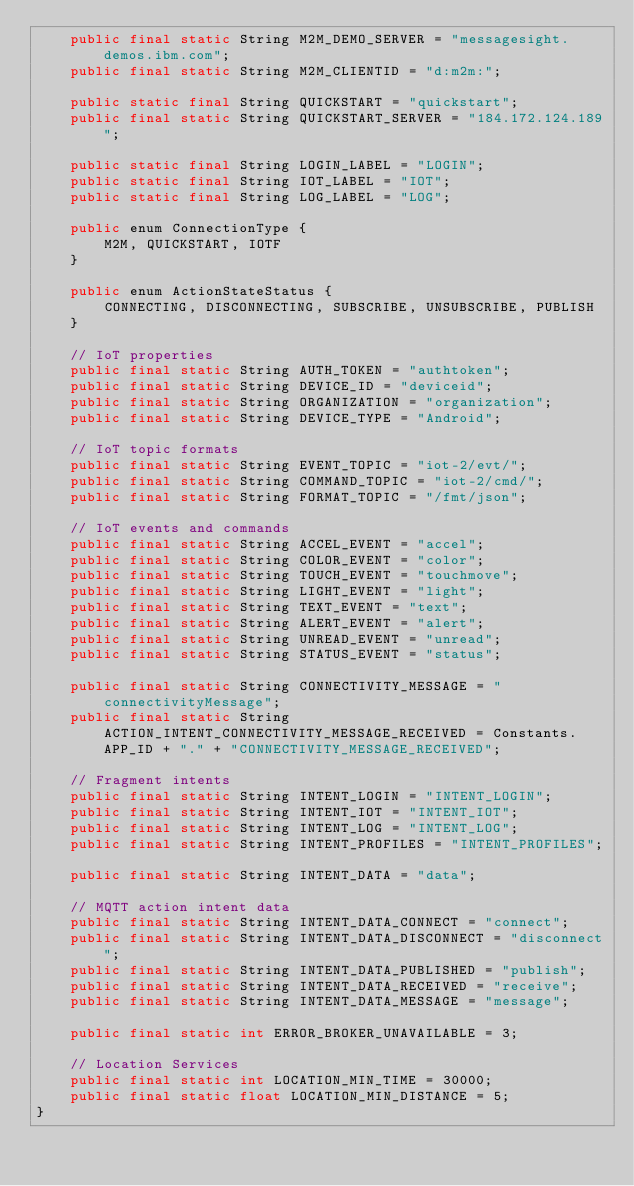Convert code to text. <code><loc_0><loc_0><loc_500><loc_500><_Java_>    public final static String M2M_DEMO_SERVER = "messagesight.demos.ibm.com";
    public final static String M2M_CLIENTID = "d:m2m:";

    public static final String QUICKSTART = "quickstart";
    public final static String QUICKSTART_SERVER = "184.172.124.189";

    public static final String LOGIN_LABEL = "LOGIN";
    public static final String IOT_LABEL = "IOT";
    public static final String LOG_LABEL = "LOG";

    public enum ConnectionType {
        M2M, QUICKSTART, IOTF
    }

    public enum ActionStateStatus {
        CONNECTING, DISCONNECTING, SUBSCRIBE, UNSUBSCRIBE, PUBLISH
    }

    // IoT properties
    public final static String AUTH_TOKEN = "authtoken";
    public final static String DEVICE_ID = "deviceid";
    public final static String ORGANIZATION = "organization";
    public final static String DEVICE_TYPE = "Android";

    // IoT topic formats
    public final static String EVENT_TOPIC = "iot-2/evt/";
    public final static String COMMAND_TOPIC = "iot-2/cmd/";
    public final static String FORMAT_TOPIC = "/fmt/json";

    // IoT events and commands
    public final static String ACCEL_EVENT = "accel";
    public final static String COLOR_EVENT = "color";
    public final static String TOUCH_EVENT = "touchmove";
    public final static String LIGHT_EVENT = "light";
    public final static String TEXT_EVENT = "text";
    public final static String ALERT_EVENT = "alert";
    public final static String UNREAD_EVENT = "unread";
    public final static String STATUS_EVENT = "status";

    public final static String CONNECTIVITY_MESSAGE = "connectivityMessage";
    public final static String ACTION_INTENT_CONNECTIVITY_MESSAGE_RECEIVED = Constants.APP_ID + "." + "CONNECTIVITY_MESSAGE_RECEIVED";

    // Fragment intents
    public final static String INTENT_LOGIN = "INTENT_LOGIN";
    public final static String INTENT_IOT = "INTENT_IOT";
    public final static String INTENT_LOG = "INTENT_LOG";
    public final static String INTENT_PROFILES = "INTENT_PROFILES";

    public final static String INTENT_DATA = "data";

    // MQTT action intent data
    public final static String INTENT_DATA_CONNECT = "connect";
    public final static String INTENT_DATA_DISCONNECT = "disconnect";
    public final static String INTENT_DATA_PUBLISHED = "publish";
    public final static String INTENT_DATA_RECEIVED = "receive";
    public final static String INTENT_DATA_MESSAGE = "message";

    public final static int ERROR_BROKER_UNAVAILABLE = 3;

    // Location Services
    public final static int LOCATION_MIN_TIME = 30000;
    public final static float LOCATION_MIN_DISTANCE = 5;
}
</code> 